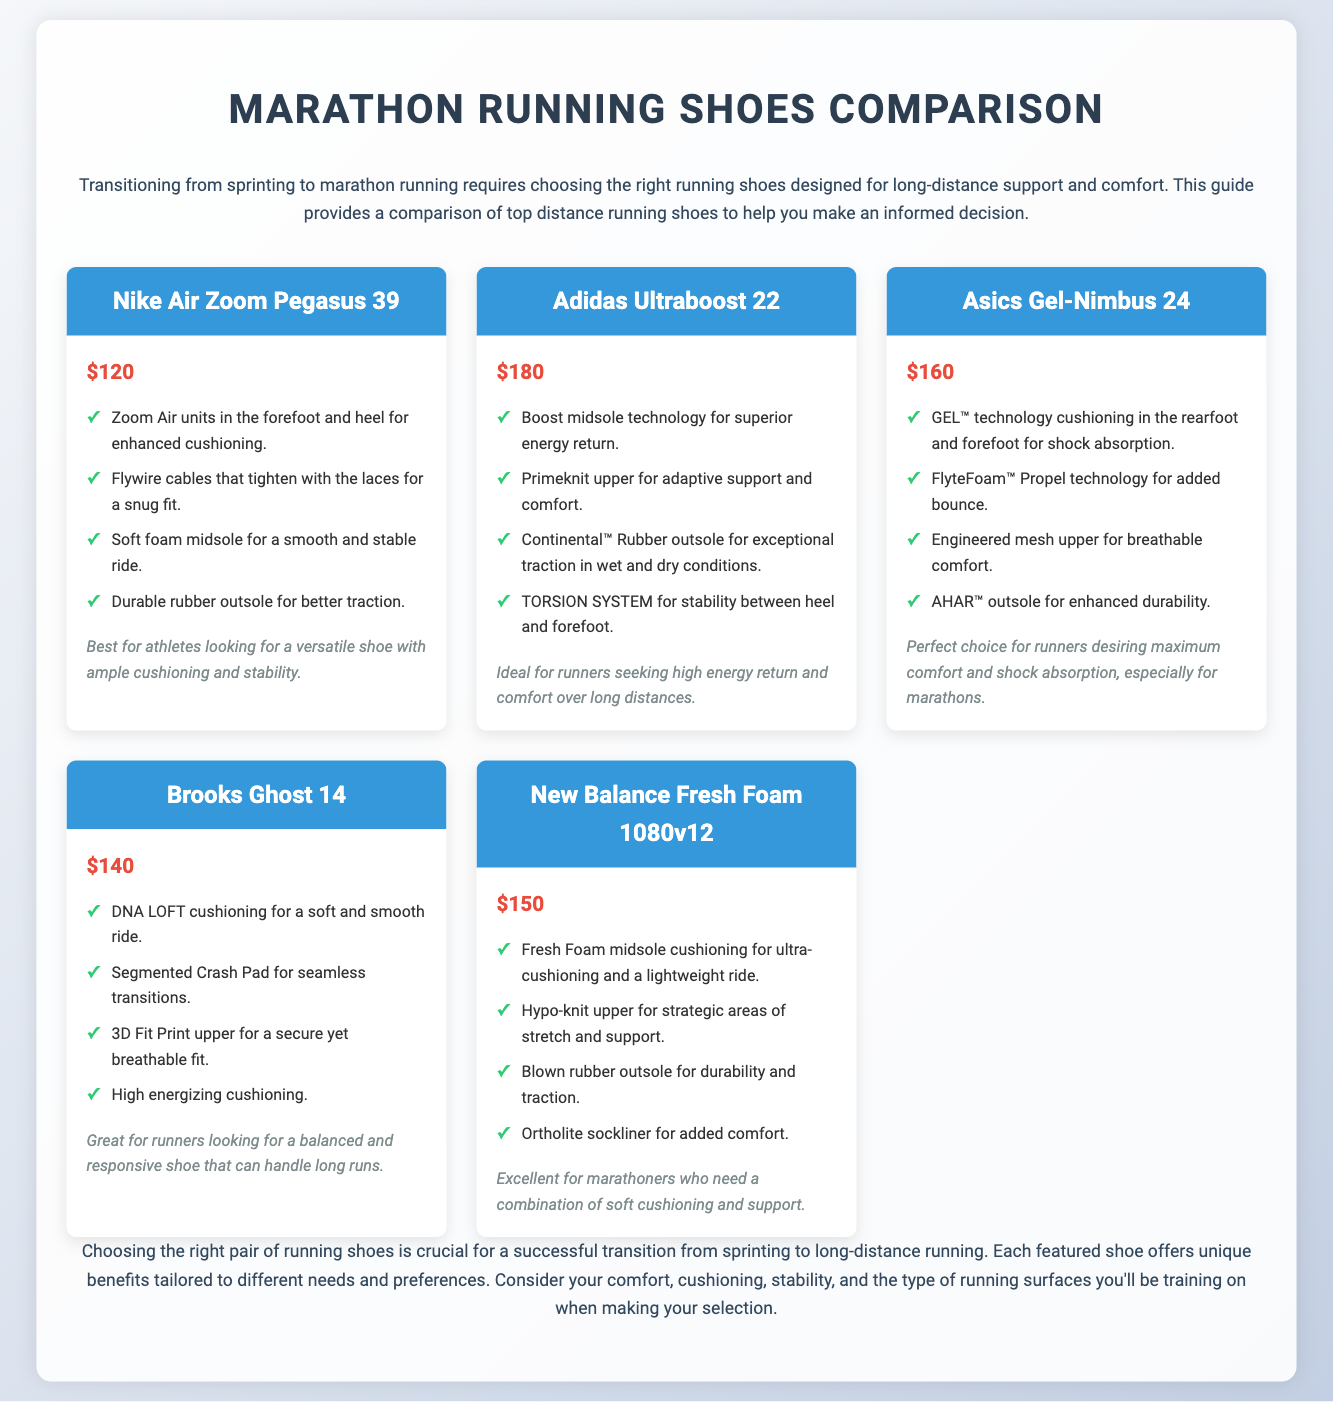What is the price of Nike Air Zoom Pegasus 39? The price of Nike Air Zoom Pegasus 39 is provided in the document, which states it is $120.
Answer: $120 Which shoe features Boost midsole technology? The document lists Adidas Ultraboost 22 as the shoe that features Boost midsole technology.
Answer: Adidas Ultraboost 22 What is unique about the Asics Gel-Nimbus 24? The Asics Gel-Nimbus 24 is noted for its GEL technology cushioning for shock absorption.
Answer: GEL technology cushioning Which shoe is ideal for runners seeking high energy return? The document specifies that Adidas Ultraboost 22 is ideal for runners seeking high energy return.
Answer: Adidas Ultraboost 22 How much does the New Balance Fresh Foam 1080v12 cost? The document states that New Balance Fresh Foam 1080v12 costs $150.
Answer: $150 What technology does Brooks Ghost 14 use for cushioning? The document indicates that Brooks Ghost 14 uses DNA LOFT cushioning for a soft ride.
Answer: DNA LOFT cushioning What type of outsole does Adidas Ultraboost 22 have? The document mentions that Adidas Ultraboost 22 has a Continental™ Rubber outsole for traction.
Answer: Continental™ Rubber outsole Which shoe offers maximum comfort and shock absorption? According to the document, the Asics Gel-Nimbus 24 is the choice for maximum comfort and shock absorption.
Answer: Asics Gel-Nimbus 24 What is the common feature of all shoes presented? The document emphasizes that all shoes are designed for marathon running, tailored for distance running support.
Answer: Designed for marathon running 